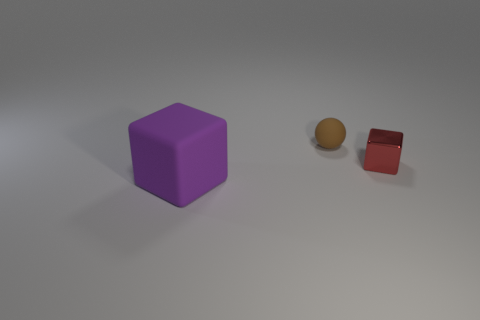Add 3 big gray metallic cylinders. How many objects exist? 6 Subtract all blocks. How many objects are left? 1 Add 1 red shiny objects. How many red shiny objects exist? 2 Subtract 0 blue cylinders. How many objects are left? 3 Subtract all small brown balls. Subtract all blue rubber blocks. How many objects are left? 2 Add 2 small brown things. How many small brown things are left? 3 